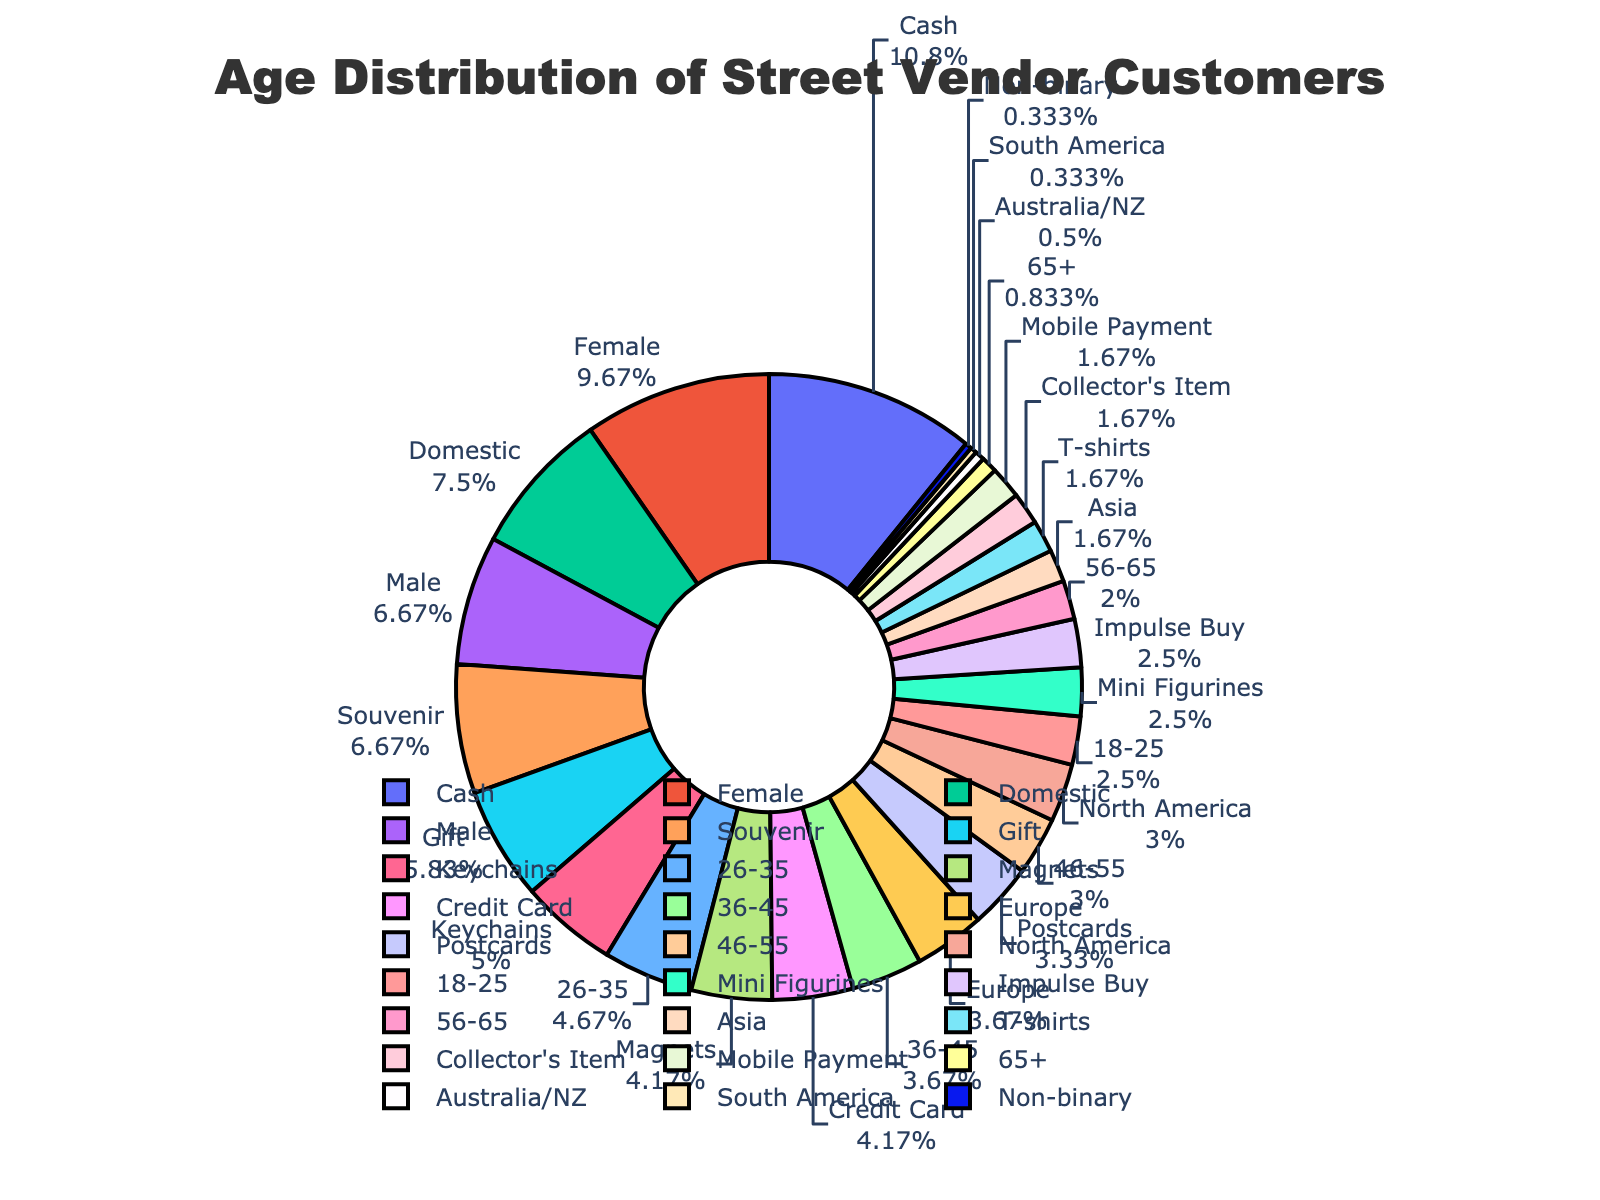Which age group has the highest percentage of customers? The pie chart shows the highest percentage in the 26-35 age group according to the segment size.
Answer: 26-35 What is the combined percentage of customers aged 36-45 and 46-55? Add the percentages of the 36-45 group (22%) and the 46-55 group (18%). 22 + 18 = 40.
Answer: 40% How does the percentage of customers aged 56-65 compare to those aged 18-25? The 56-65 age group is 12%, and the 18-25 age group is 15%, meaning 56-65 has a lower percentage.
Answer: Lower Which age group occupies the smallest segment of the pie chart, and what is its percentage? The smallest segment is 65+, and its percentage is clearly marked as 5%.
Answer: 65+, 5% What is the percentage difference between the largest and smallest age groups? Subtract the smallest percentage (5% for 65+) from the largest percentage (28% for 26-35). 28 - 5 = 23.
Answer: 23% What is the visual color used for the age group 36-45? The age group 36-45 is marked in green according to the pie chart.
Answer: Green Which two adjacent age groups combined make up close to half of the customers? Adding percentages of adjacent groups: 26-35 (28%) + 36-45 (22%) = 50%. These combined make up half.
Answer: 26-35 and 36-45 Compare the percentages of customers aged 18-25 and 65+. Which group is larger and by how much? The 18-25 group is 15%, and the 65+ group is 5%. 15 - 5 = 10.
Answer: 18-25, by 10% How does the middle age group's (36-45) customer percentage compare to the overall sum of the youngest (18-25) and oldest (65+) age groups? 36-45 has 22%, while 18-25 + 65+ is 15 + 5 = 20%. 22% is larger.
Answer: Larger Which age group is represented by a yellow segment? According to the chart's key, the 65+ group is represented by yellow.
Answer: 65+ 